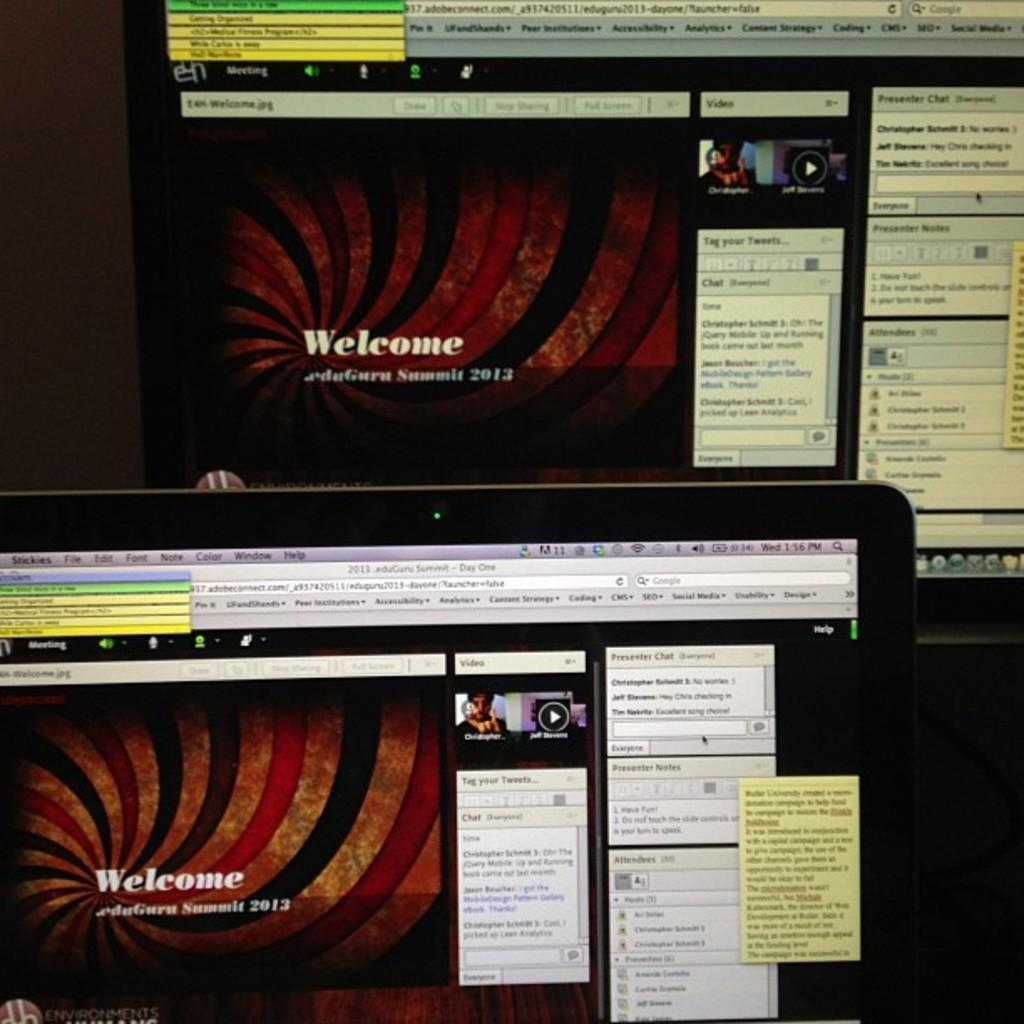<image>
Create a compact narrative representing the image presented. Two computer screens display the same Welcome screen for a 2013 event. 